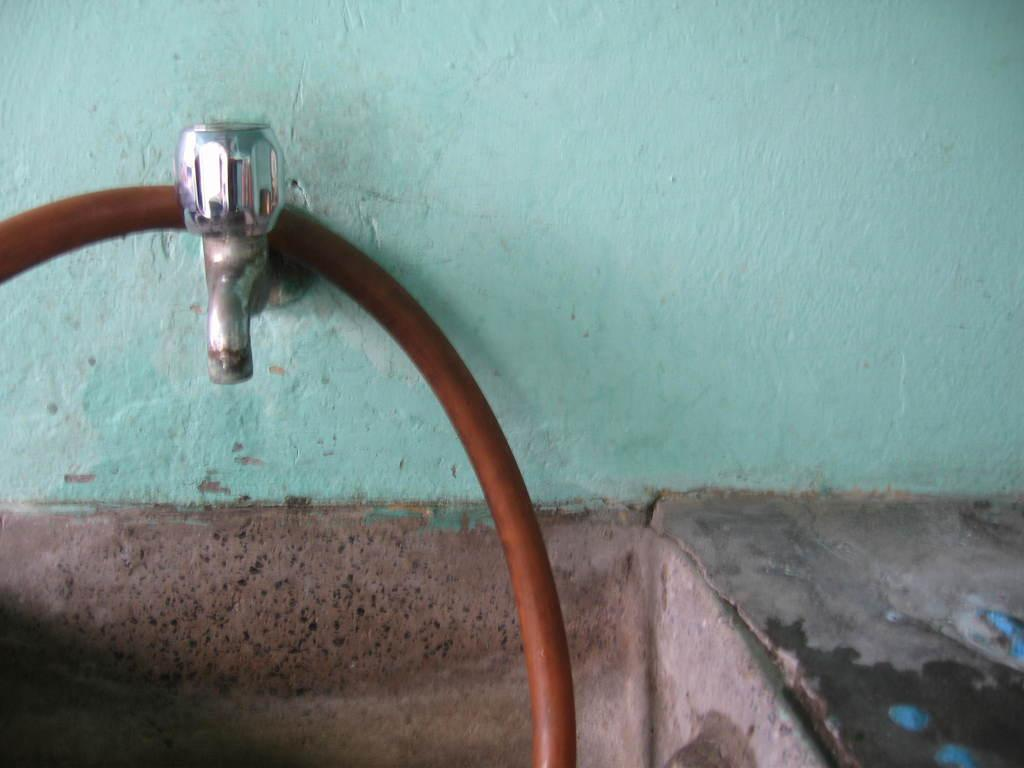What can be seen in the image that is used for dispensing water? There is a water tap in the image. What type of pipe is visible in the image? There is a brown-colored pipe in the image. How many dimes are placed on the wall in the image? There are no dimes present in the image; it only features a water tap and a brown-colored pipe. What type of vase can be seen holding flowers in the image? There is no vase holding flowers in the image; it only features a water tap and a brown-colored pipe. 